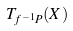<formula> <loc_0><loc_0><loc_500><loc_500>T _ { f ^ { - 1 } P } ( X )</formula> 